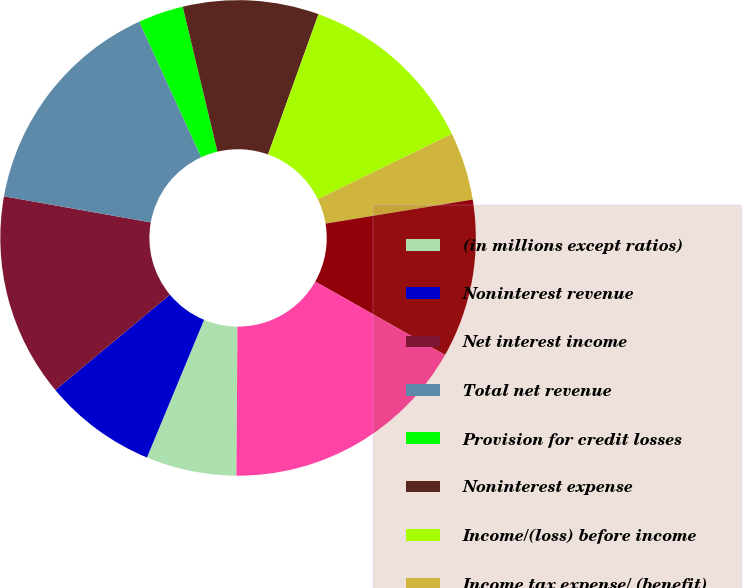Convert chart to OTSL. <chart><loc_0><loc_0><loc_500><loc_500><pie_chart><fcel>(in millions except ratios)<fcel>Noninterest revenue<fcel>Net interest income<fcel>Total net revenue<fcel>Provision for credit losses<fcel>Noninterest expense<fcel>Income/(loss) before income<fcel>Income tax expense/ (benefit)<fcel>Net income/(loss)<fcel>Average common equity<nl><fcel>6.15%<fcel>7.69%<fcel>13.85%<fcel>15.38%<fcel>3.08%<fcel>9.23%<fcel>12.31%<fcel>4.62%<fcel>10.77%<fcel>16.92%<nl></chart> 